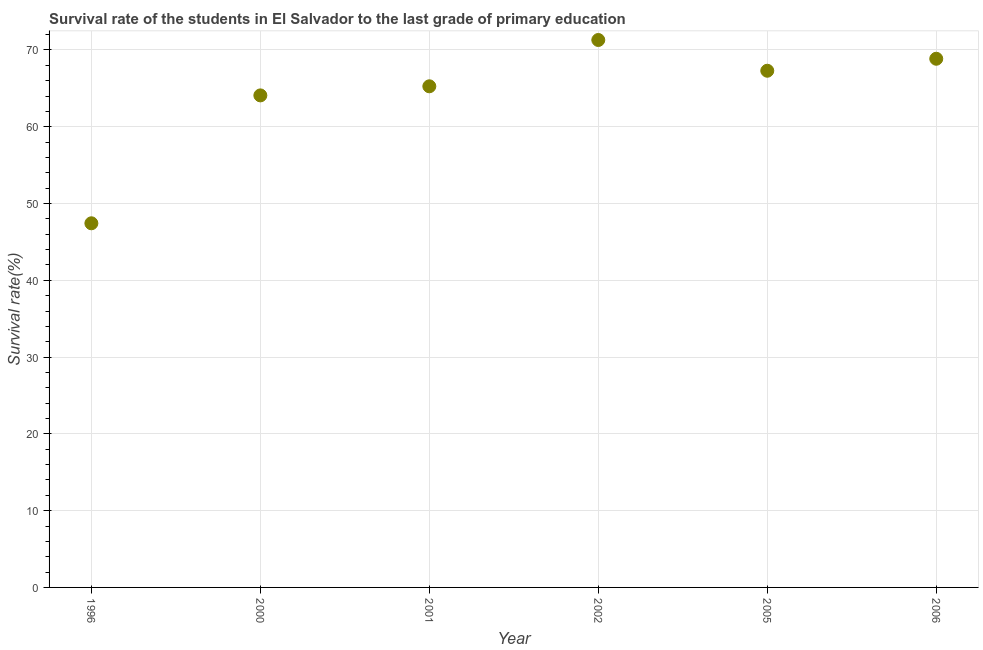What is the survival rate in primary education in 2001?
Your response must be concise. 65.27. Across all years, what is the maximum survival rate in primary education?
Keep it short and to the point. 71.3. Across all years, what is the minimum survival rate in primary education?
Provide a succinct answer. 47.42. In which year was the survival rate in primary education minimum?
Keep it short and to the point. 1996. What is the sum of the survival rate in primary education?
Your response must be concise. 384.22. What is the difference between the survival rate in primary education in 2002 and 2006?
Offer a terse response. 2.44. What is the average survival rate in primary education per year?
Offer a terse response. 64.04. What is the median survival rate in primary education?
Provide a short and direct response. 66.28. In how many years, is the survival rate in primary education greater than 18 %?
Make the answer very short. 6. Do a majority of the years between 1996 and 2000 (inclusive) have survival rate in primary education greater than 48 %?
Provide a short and direct response. No. What is the ratio of the survival rate in primary education in 2000 to that in 2005?
Your response must be concise. 0.95. Is the survival rate in primary education in 2000 less than that in 2001?
Make the answer very short. Yes. What is the difference between the highest and the second highest survival rate in primary education?
Your answer should be compact. 2.44. Is the sum of the survival rate in primary education in 1996 and 2005 greater than the maximum survival rate in primary education across all years?
Offer a terse response. Yes. What is the difference between the highest and the lowest survival rate in primary education?
Make the answer very short. 23.87. In how many years, is the survival rate in primary education greater than the average survival rate in primary education taken over all years?
Give a very brief answer. 5. How many dotlines are there?
Your answer should be very brief. 1. Are the values on the major ticks of Y-axis written in scientific E-notation?
Make the answer very short. No. Does the graph contain grids?
Offer a terse response. Yes. What is the title of the graph?
Offer a very short reply. Survival rate of the students in El Salvador to the last grade of primary education. What is the label or title of the Y-axis?
Keep it short and to the point. Survival rate(%). What is the Survival rate(%) in 1996?
Your answer should be compact. 47.42. What is the Survival rate(%) in 2000?
Your answer should be very brief. 64.08. What is the Survival rate(%) in 2001?
Provide a short and direct response. 65.27. What is the Survival rate(%) in 2002?
Provide a short and direct response. 71.3. What is the Survival rate(%) in 2005?
Make the answer very short. 67.29. What is the Survival rate(%) in 2006?
Your answer should be compact. 68.86. What is the difference between the Survival rate(%) in 1996 and 2000?
Give a very brief answer. -16.66. What is the difference between the Survival rate(%) in 1996 and 2001?
Keep it short and to the point. -17.84. What is the difference between the Survival rate(%) in 1996 and 2002?
Your response must be concise. -23.87. What is the difference between the Survival rate(%) in 1996 and 2005?
Offer a very short reply. -19.87. What is the difference between the Survival rate(%) in 1996 and 2006?
Offer a terse response. -21.43. What is the difference between the Survival rate(%) in 2000 and 2001?
Offer a very short reply. -1.18. What is the difference between the Survival rate(%) in 2000 and 2002?
Make the answer very short. -7.22. What is the difference between the Survival rate(%) in 2000 and 2005?
Give a very brief answer. -3.21. What is the difference between the Survival rate(%) in 2000 and 2006?
Your answer should be compact. -4.77. What is the difference between the Survival rate(%) in 2001 and 2002?
Your response must be concise. -6.03. What is the difference between the Survival rate(%) in 2001 and 2005?
Keep it short and to the point. -2.03. What is the difference between the Survival rate(%) in 2001 and 2006?
Provide a short and direct response. -3.59. What is the difference between the Survival rate(%) in 2002 and 2005?
Give a very brief answer. 4.01. What is the difference between the Survival rate(%) in 2002 and 2006?
Your answer should be compact. 2.44. What is the difference between the Survival rate(%) in 2005 and 2006?
Offer a terse response. -1.56. What is the ratio of the Survival rate(%) in 1996 to that in 2000?
Give a very brief answer. 0.74. What is the ratio of the Survival rate(%) in 1996 to that in 2001?
Keep it short and to the point. 0.73. What is the ratio of the Survival rate(%) in 1996 to that in 2002?
Ensure brevity in your answer.  0.67. What is the ratio of the Survival rate(%) in 1996 to that in 2005?
Ensure brevity in your answer.  0.7. What is the ratio of the Survival rate(%) in 1996 to that in 2006?
Keep it short and to the point. 0.69. What is the ratio of the Survival rate(%) in 2000 to that in 2001?
Provide a succinct answer. 0.98. What is the ratio of the Survival rate(%) in 2000 to that in 2002?
Give a very brief answer. 0.9. What is the ratio of the Survival rate(%) in 2001 to that in 2002?
Give a very brief answer. 0.92. What is the ratio of the Survival rate(%) in 2001 to that in 2006?
Your answer should be very brief. 0.95. What is the ratio of the Survival rate(%) in 2002 to that in 2005?
Ensure brevity in your answer.  1.06. What is the ratio of the Survival rate(%) in 2002 to that in 2006?
Give a very brief answer. 1.03. What is the ratio of the Survival rate(%) in 2005 to that in 2006?
Ensure brevity in your answer.  0.98. 